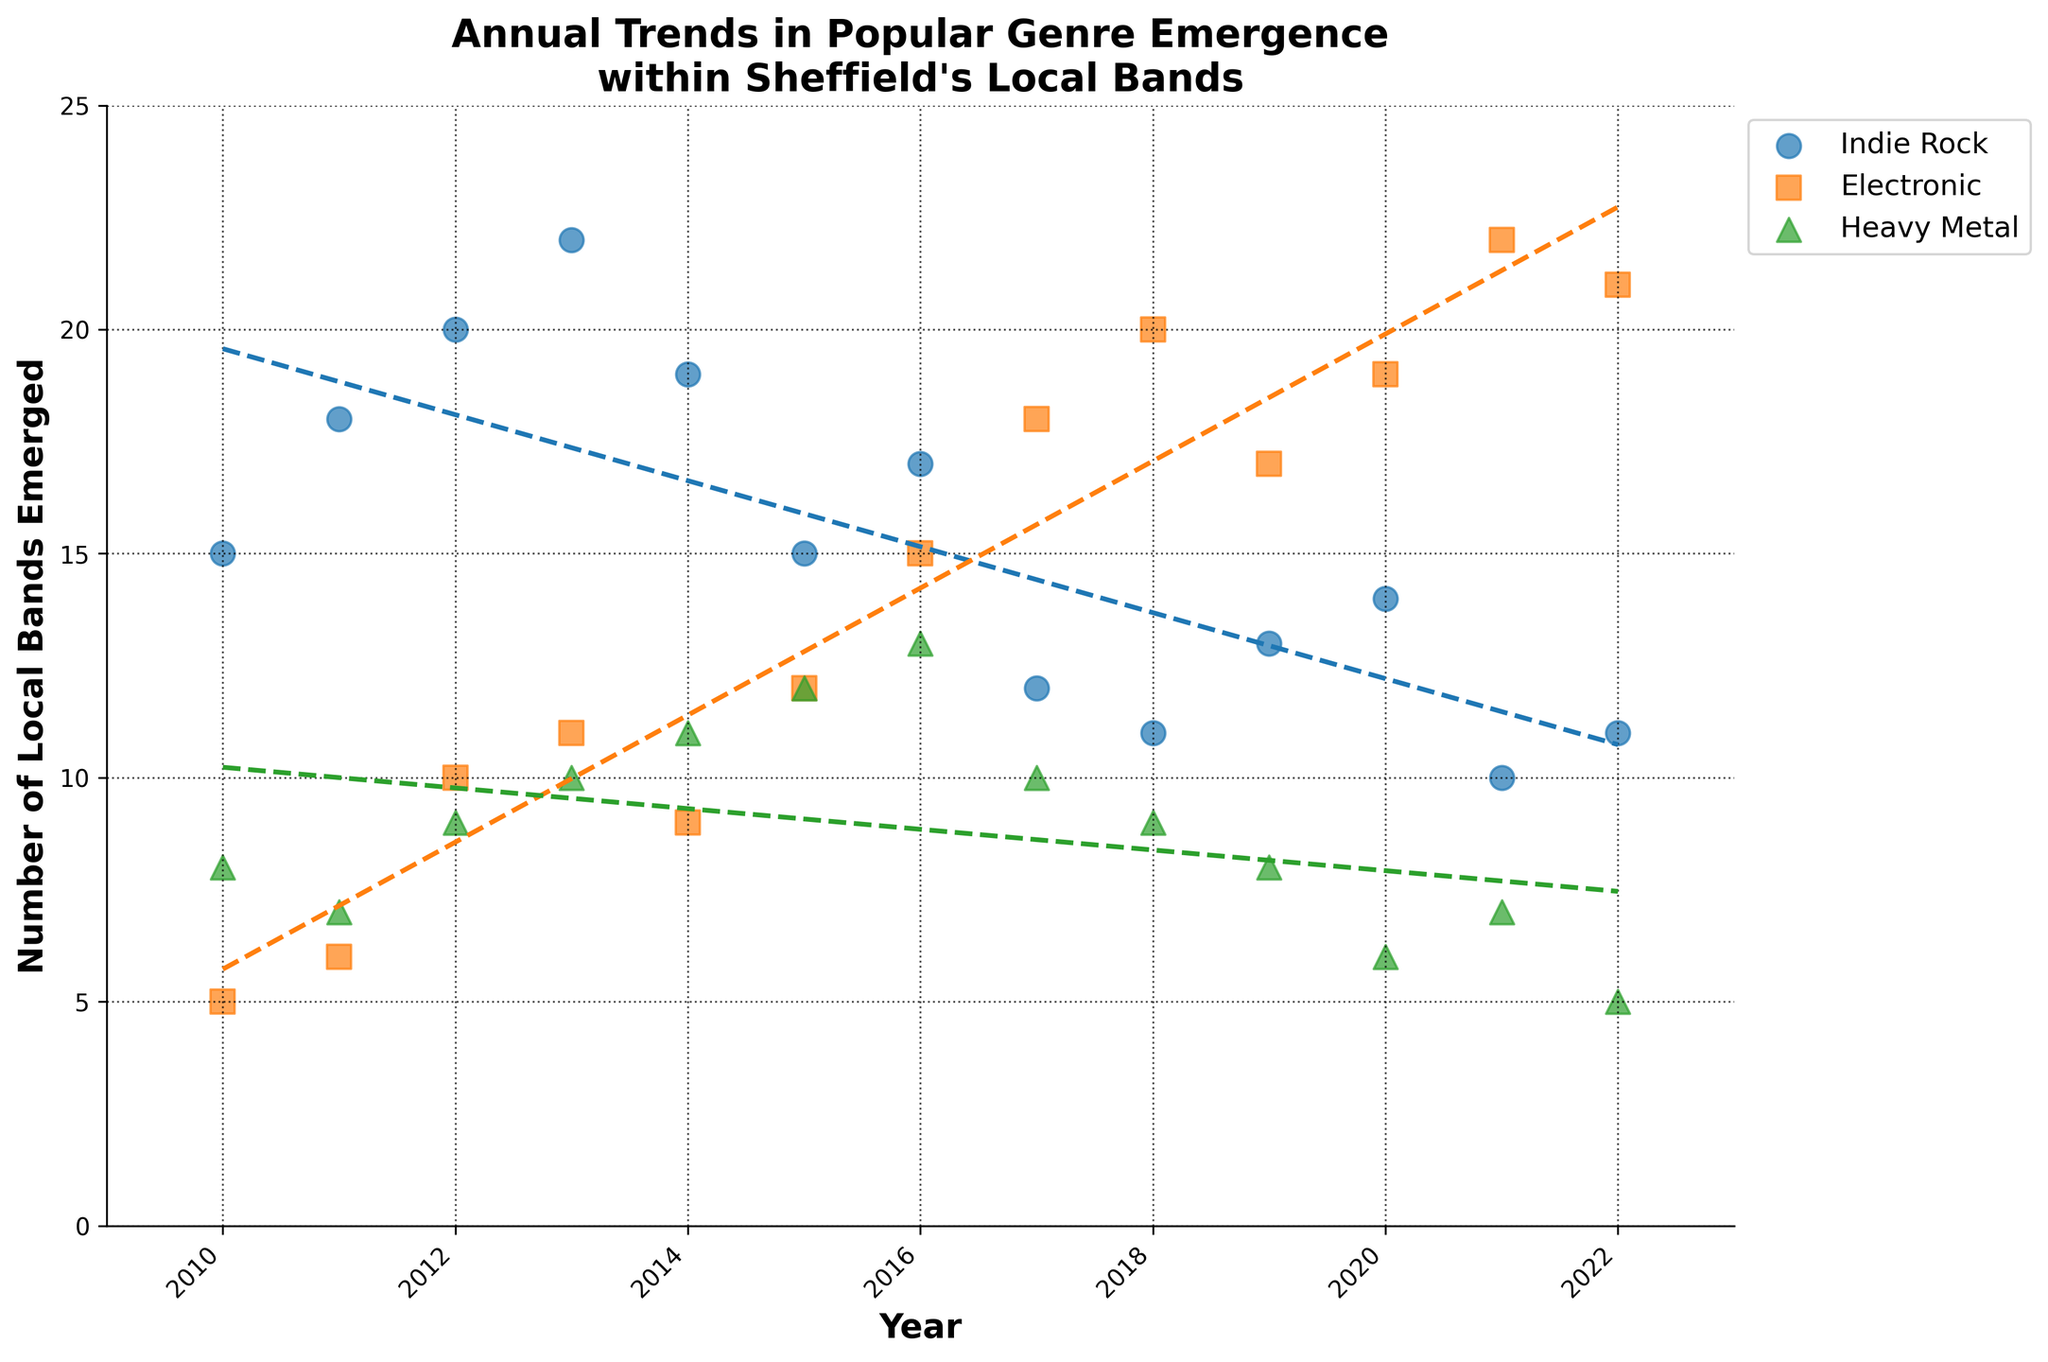Which genre saw the highest number of local bands emerged in 2017? Look for the highest data points in the year 2017; "Electronic" genre has the highest value in this year.
Answer: Electronic How many Indie Rock bands emerged in 2010? Locate the data points for "Indie Rock" in the year 2010; it is labeled as 15.
Answer: 15 What is the trend in Heavy Metal bands between 2010 and 2022? Examine the dashed line for "Heavy Metal"; it indicates a general decline over the years.
Answer: Decline Which genre has the steepest upward trend? Compare the slopes of the trend lines; Electronic has the steepest upward slope.
Answer: Electronic Between which two years did Electronic bands see the most significant rise in numbers? Compare the data points for "Electronic" across years; the most significant rise occurs between 2016 and 2017.
Answer: 2016 and 2017 How many local bands emerged in total across all genres in 2015? Sum up the data points for all genres in 2015: 15 (Indie Rock) + 12 (Electronic) + 12 (Heavy Metal) = 39.
Answer: 39 Which genre saw a decrease in the number of bands emerged from 2010 to 2022? Compare the data points from 2010 to 2022 for each genre; Indie Rock and Heavy Metal show a decrease.
Answer: Indie Rock and Heavy Metal What is the title of the figure? Read the text at the top center of the figure; it is "Annual Trends in Popular Genre Emergence within Sheffield's Local Bands".
Answer: Annual Trends in Popular Genre Emergence within Sheffield's Local Bands Compare the number of Electronic bands emerged in 2018 and 2019. Which year had more? Look at the data points for "Electronic" in 2018 and 2019; 2018 has more with 20 compared to 17 in 2019.
Answer: 2018 What colors represent each genre? Identify the color and marker codes for each genre; Indie Rock is blue, Electronic is orange, Heavy Metal is green.
Answer: Indie Rock is blue, Electronic is orange, Heavy Metal is green 